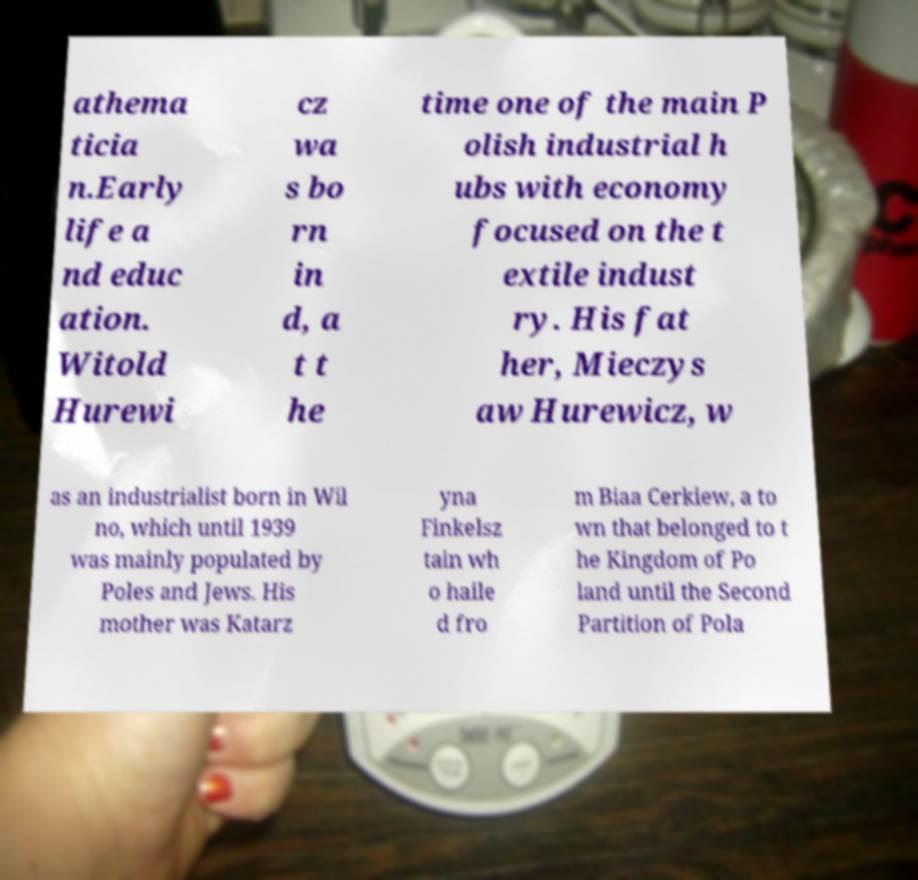Can you accurately transcribe the text from the provided image for me? athema ticia n.Early life a nd educ ation. Witold Hurewi cz wa s bo rn in d, a t t he time one of the main P olish industrial h ubs with economy focused on the t extile indust ry. His fat her, Mieczys aw Hurewicz, w as an industrialist born in Wil no, which until 1939 was mainly populated by Poles and Jews. His mother was Katarz yna Finkelsz tain wh o haile d fro m Biaa Cerkiew, a to wn that belonged to t he Kingdom of Po land until the Second Partition of Pola 